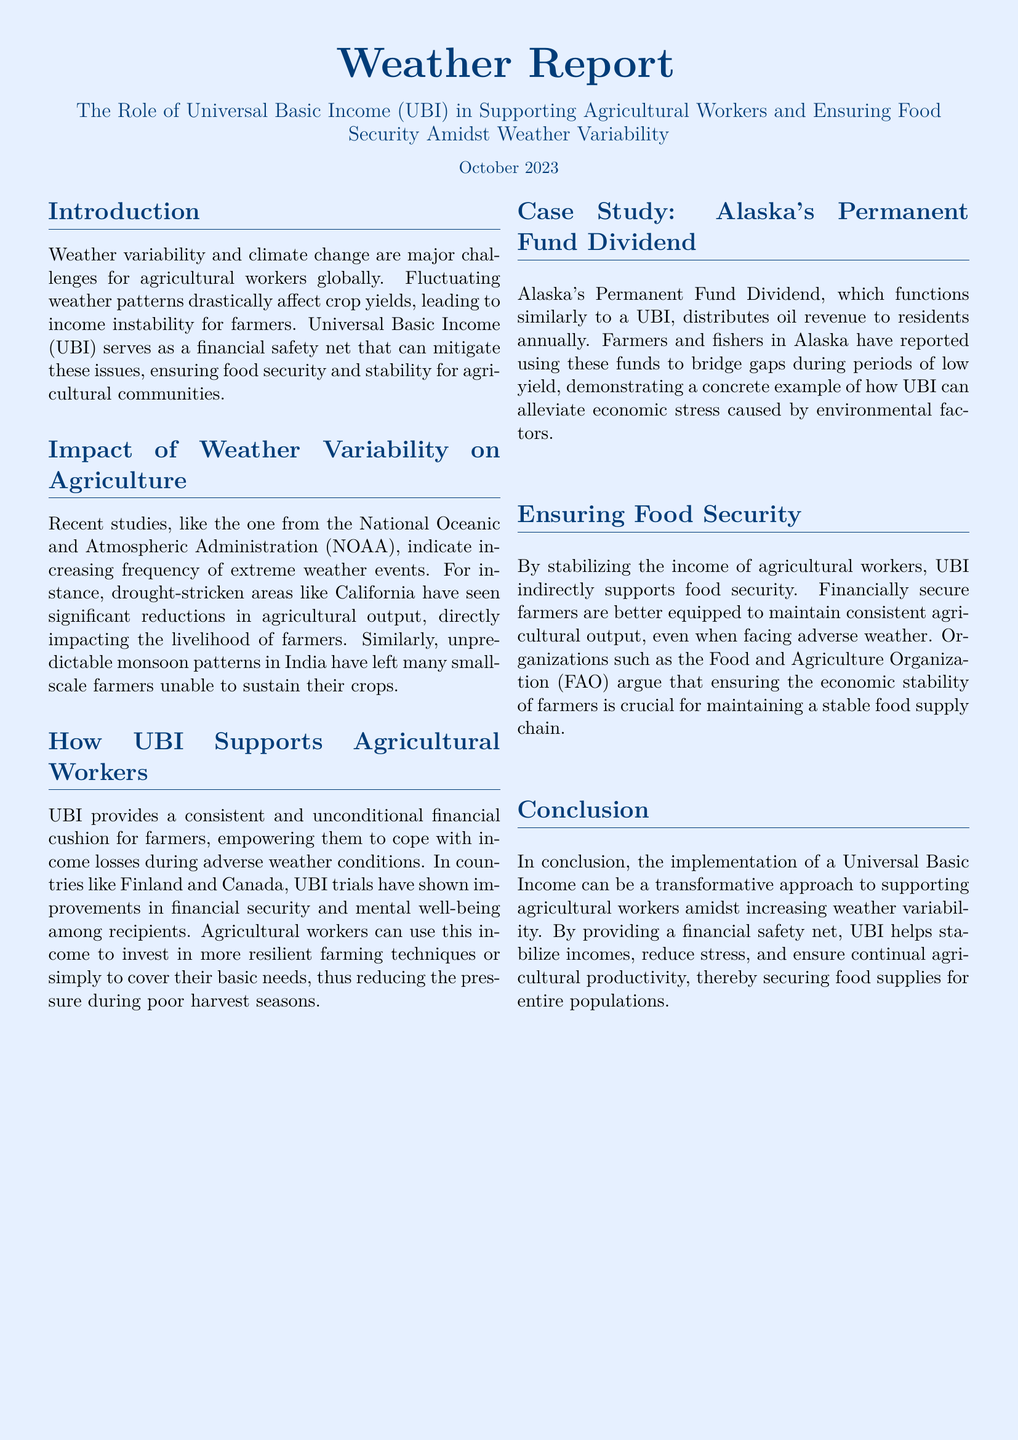what is the title of the document? The title of the document is stated at the top, highlighting the focus on UBI and its role in agriculture.
Answer: Weather Report when was this document published? The publication date is mentioned clearly in the document.
Answer: October 2023 what is one major challenge that agricultural workers face according to the document? The document lists several challenges, and one of them is clearly stated in the introduction.
Answer: Weather variability which countries showed positive outcomes from UBI trials? The document specifically mentions two countries where UBI trials were conducted with strong results.
Answer: Finland and Canada what is the case study referenced in the document? The document includes a specific example that illustrates the effectiveness of a UBI-like initiative.
Answer: Alaska's Permanent Fund Dividend how does UBI indirectly support food security? The document explains the relationship between UBI and food security through financial stability for farmers.
Answer: Stabilizing income who argues that ensuring the economic stability of farmers is crucial? A specific organization is mentioned in the document that emphasizes the importance of farmer stability for food security.
Answer: Food and Agriculture Organization (FAO) what did farmers and fishers in Alaska use their funds for? The document provides insights on how the UBI funds were utilized by local agricultural workers.
Answer: Bridge gaps during periods of low yield what are farmers empowered to do with UBI? The document elaborates on the benefits that UBI bestows upon farmers when faced with adverse situations.
Answer: Cope with income losses 